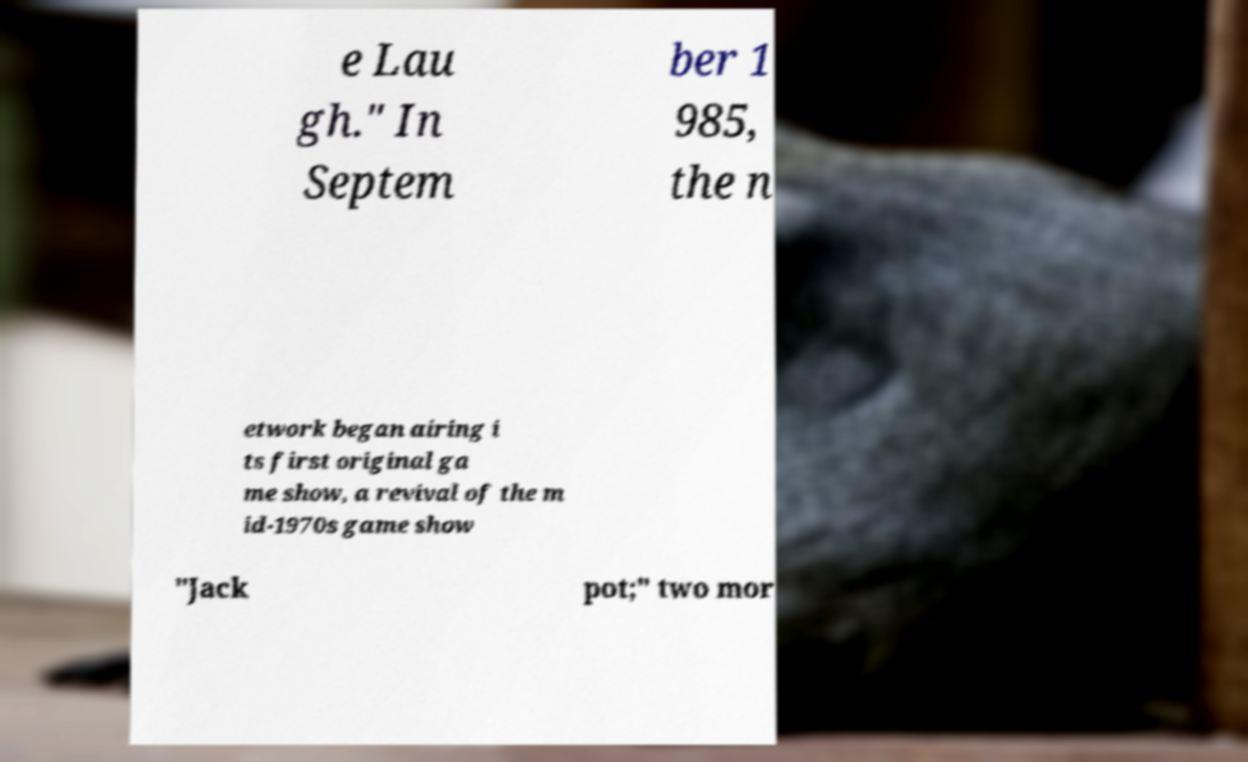For documentation purposes, I need the text within this image transcribed. Could you provide that? e Lau gh." In Septem ber 1 985, the n etwork began airing i ts first original ga me show, a revival of the m id-1970s game show "Jack pot;" two mor 